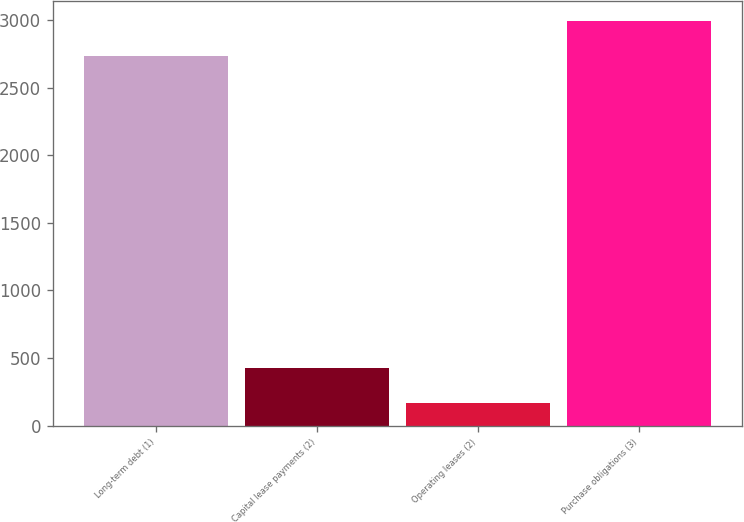<chart> <loc_0><loc_0><loc_500><loc_500><bar_chart><fcel>Long-term debt (1)<fcel>Capital lease payments (2)<fcel>Operating leases (2)<fcel>Purchase obligations (3)<nl><fcel>2731<fcel>428.5<fcel>166<fcel>2993.5<nl></chart> 